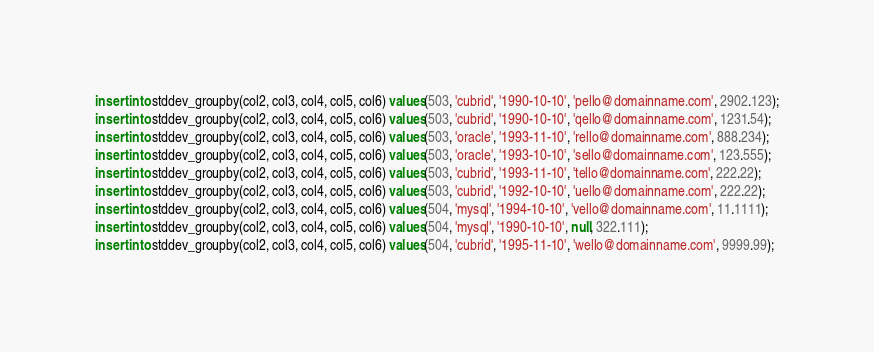<code> <loc_0><loc_0><loc_500><loc_500><_SQL_>insert into stddev_groupby(col2, col3, col4, col5, col6) values(503, 'cubrid', '1990-10-10', 'pello@domainname.com', 2902.123);
insert into stddev_groupby(col2, col3, col4, col5, col6) values(503, 'cubrid', '1990-10-10', 'qello@domainname.com', 1231.54);
insert into stddev_groupby(col2, col3, col4, col5, col6) values(503, 'oracle', '1993-11-10', 'rello@domainname.com', 888.234);
insert into stddev_groupby(col2, col3, col4, col5, col6) values(503, 'oracle', '1993-10-10', 'sello@domainname.com', 123.555);
insert into stddev_groupby(col2, col3, col4, col5, col6) values(503, 'cubrid', '1993-11-10', 'tello@domainname.com', 222.22);
insert into stddev_groupby(col2, col3, col4, col5, col6) values(503, 'cubrid', '1992-10-10', 'uello@domainname.com', 222.22);
insert into stddev_groupby(col2, col3, col4, col5, col6) values(504, 'mysql', '1994-10-10', 'vello@domainname.com', 11.1111);
insert into stddev_groupby(col2, col3, col4, col5, col6) values(504, 'mysql', '1990-10-10', null, 322.111);
insert into stddev_groupby(col2, col3, col4, col5, col6) values(504, 'cubrid', '1995-11-10', 'wello@domainname.com', 9999.99);</code> 